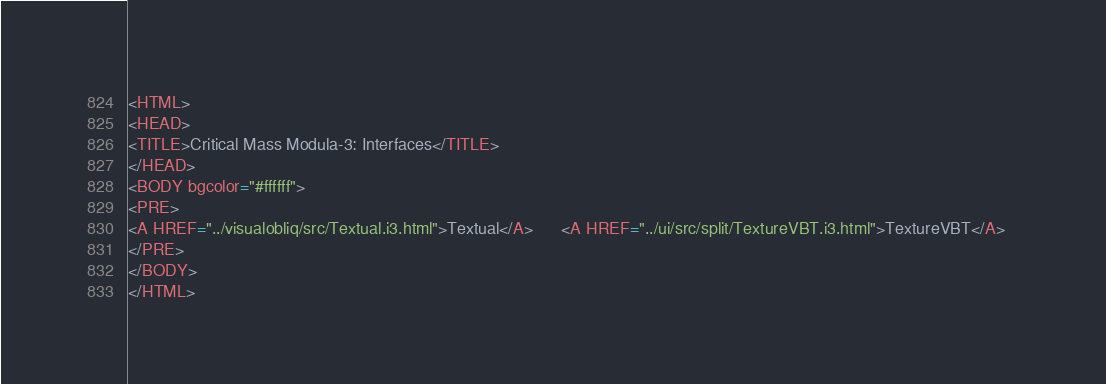Convert code to text. <code><loc_0><loc_0><loc_500><loc_500><_HTML_><HTML>
<HEAD>
<TITLE>Critical Mass Modula-3: Interfaces</TITLE>
</HEAD>
<BODY bgcolor="#ffffff">
<PRE>
<A HREF="../visualobliq/src/Textual.i3.html">Textual</A>      <A HREF="../ui/src/split/TextureVBT.i3.html">TextureVBT</A>   
</PRE>
</BODY>
</HTML>
</code> 